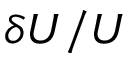<formula> <loc_0><loc_0><loc_500><loc_500>\delta U / U</formula> 